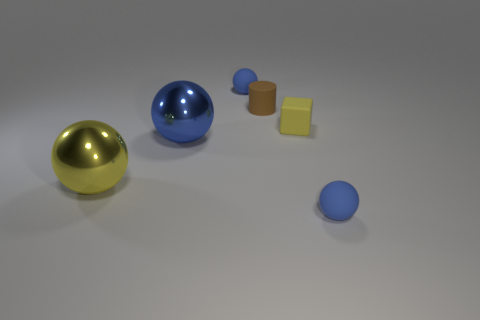Can you describe the different colors and textures present in this image? Certainly! The image features a variety of colors and textures. There's a shiny blue sphere and a glossy gold sphere that reflect light, giving them a metallic texture. Adjacent to these are two cylinders, one with a matte brown texture and the other with a reflective silver surface. Additionally, there are two flat objects; one seems to be pale yellow with a softer texture, and the other is a small blue circle with a similar smooth, matte finish as the cylinders. 